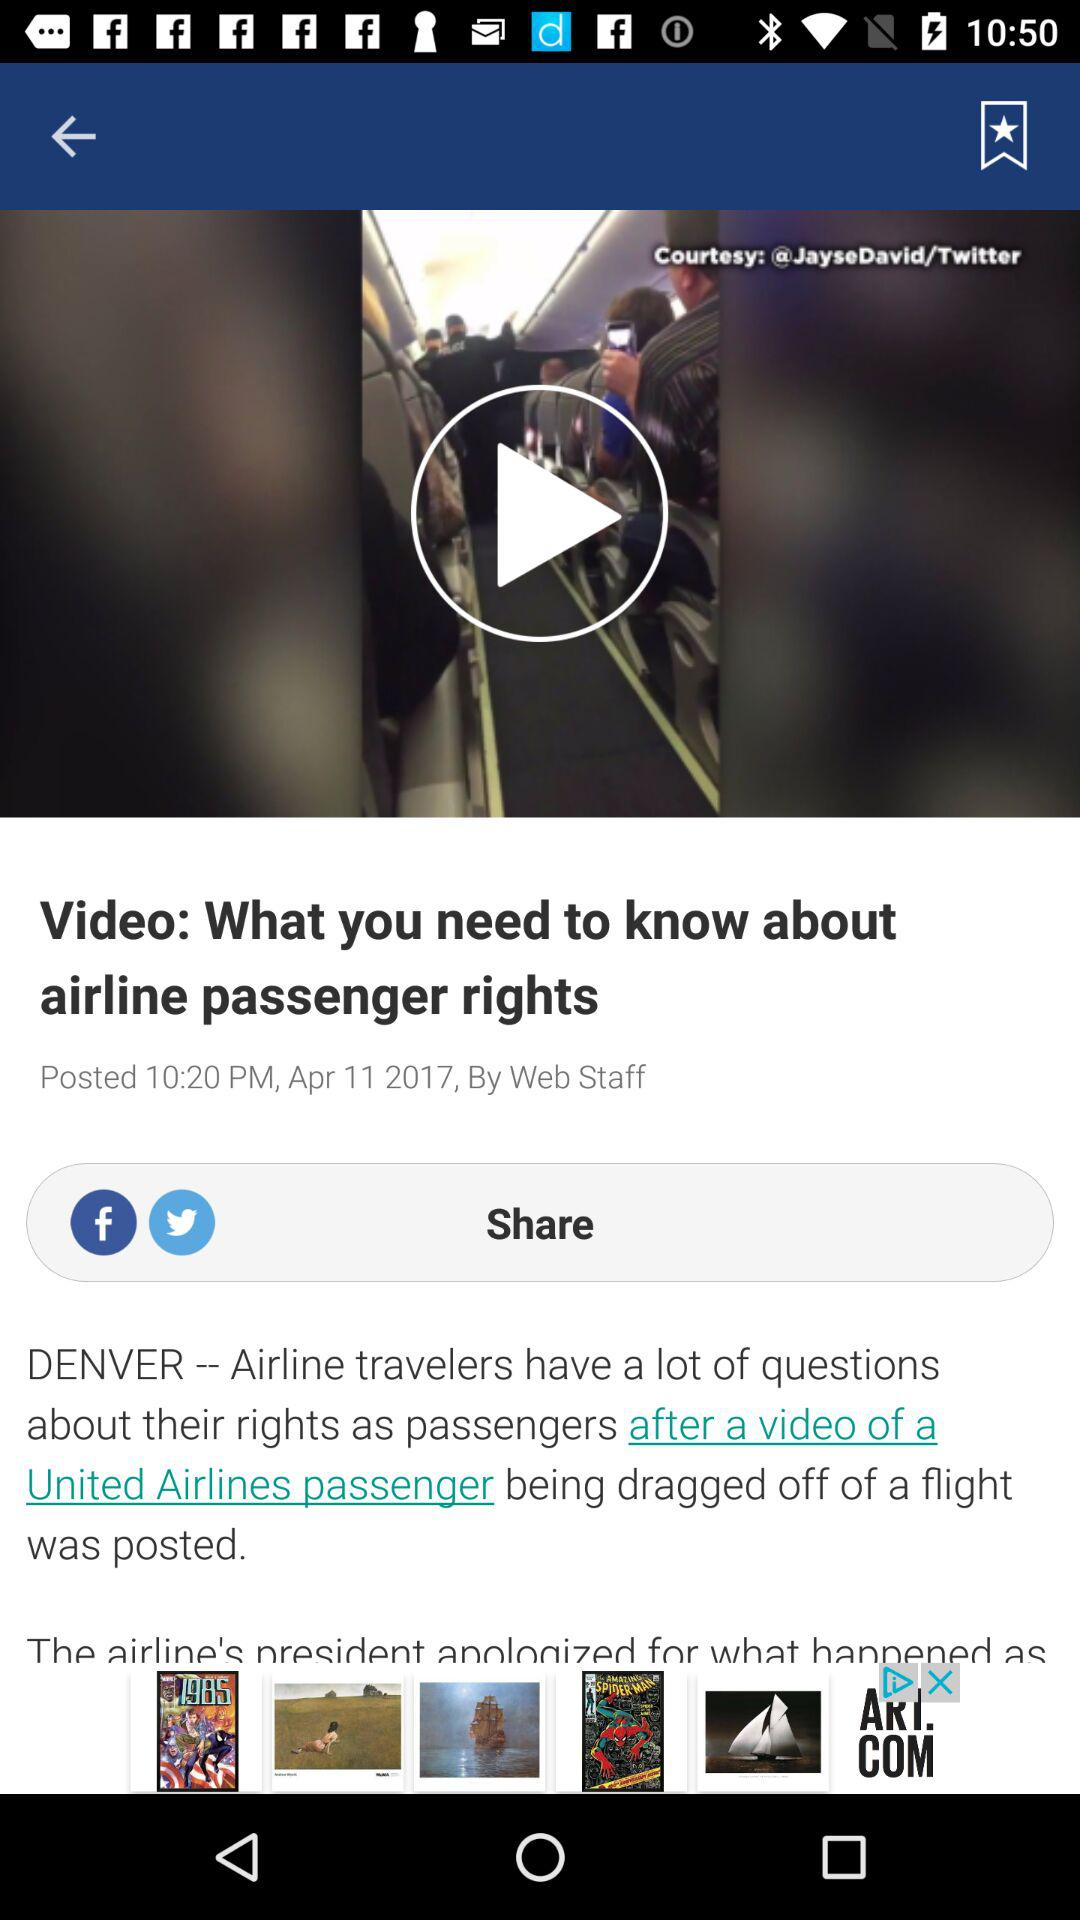Which applications can we use to share? You can use the "Facebook" and "Twitter" applications to share. 